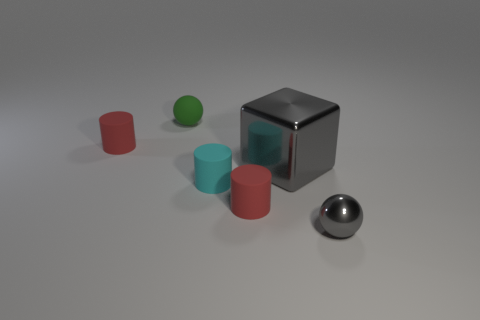Add 1 tiny cylinders. How many objects exist? 7 Subtract all blocks. How many objects are left? 5 Add 5 blocks. How many blocks exist? 6 Subtract 0 purple cylinders. How many objects are left? 6 Subtract all green objects. Subtract all tiny red rubber cylinders. How many objects are left? 3 Add 3 cubes. How many cubes are left? 4 